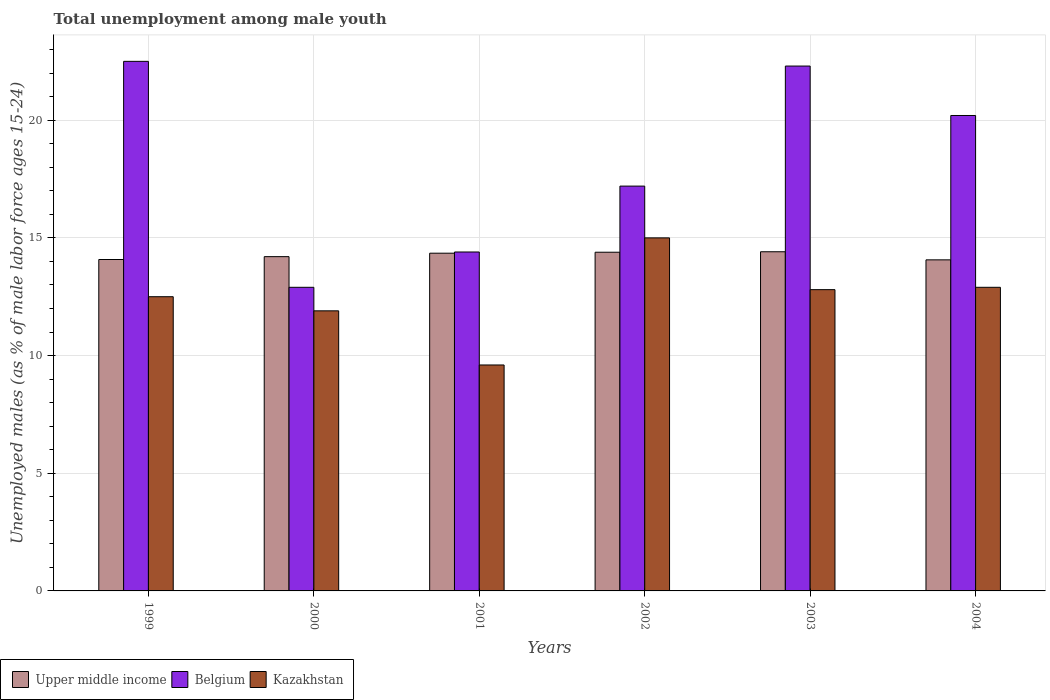How many different coloured bars are there?
Your response must be concise. 3. What is the percentage of unemployed males in in Upper middle income in 2000?
Your answer should be compact. 14.2. Across all years, what is the maximum percentage of unemployed males in in Belgium?
Your answer should be very brief. 22.5. Across all years, what is the minimum percentage of unemployed males in in Upper middle income?
Offer a terse response. 14.07. In which year was the percentage of unemployed males in in Upper middle income minimum?
Your answer should be very brief. 2004. What is the total percentage of unemployed males in in Upper middle income in the graph?
Offer a terse response. 85.5. What is the difference between the percentage of unemployed males in in Kazakhstan in 2001 and the percentage of unemployed males in in Upper middle income in 1999?
Provide a succinct answer. -4.48. What is the average percentage of unemployed males in in Belgium per year?
Your answer should be compact. 18.25. In the year 2002, what is the difference between the percentage of unemployed males in in Kazakhstan and percentage of unemployed males in in Belgium?
Provide a succinct answer. -2.2. What is the ratio of the percentage of unemployed males in in Upper middle income in 1999 to that in 2002?
Keep it short and to the point. 0.98. Is the percentage of unemployed males in in Upper middle income in 1999 less than that in 2003?
Ensure brevity in your answer.  Yes. Is the difference between the percentage of unemployed males in in Kazakhstan in 2001 and 2003 greater than the difference between the percentage of unemployed males in in Belgium in 2001 and 2003?
Offer a terse response. Yes. What is the difference between the highest and the second highest percentage of unemployed males in in Belgium?
Give a very brief answer. 0.2. What is the difference between the highest and the lowest percentage of unemployed males in in Upper middle income?
Your answer should be compact. 0.34. What does the 1st bar from the left in 2004 represents?
Offer a terse response. Upper middle income. What does the 3rd bar from the right in 1999 represents?
Your answer should be very brief. Upper middle income. Are all the bars in the graph horizontal?
Provide a succinct answer. No. Are the values on the major ticks of Y-axis written in scientific E-notation?
Provide a succinct answer. No. Does the graph contain any zero values?
Your response must be concise. No. Does the graph contain grids?
Offer a terse response. Yes. What is the title of the graph?
Offer a terse response. Total unemployment among male youth. What is the label or title of the Y-axis?
Provide a short and direct response. Unemployed males (as % of male labor force ages 15-24). What is the Unemployed males (as % of male labor force ages 15-24) in Upper middle income in 1999?
Give a very brief answer. 14.08. What is the Unemployed males (as % of male labor force ages 15-24) in Kazakhstan in 1999?
Make the answer very short. 12.5. What is the Unemployed males (as % of male labor force ages 15-24) of Upper middle income in 2000?
Offer a terse response. 14.2. What is the Unemployed males (as % of male labor force ages 15-24) of Belgium in 2000?
Offer a terse response. 12.9. What is the Unemployed males (as % of male labor force ages 15-24) of Kazakhstan in 2000?
Provide a succinct answer. 11.9. What is the Unemployed males (as % of male labor force ages 15-24) of Upper middle income in 2001?
Provide a short and direct response. 14.35. What is the Unemployed males (as % of male labor force ages 15-24) in Belgium in 2001?
Give a very brief answer. 14.4. What is the Unemployed males (as % of male labor force ages 15-24) in Kazakhstan in 2001?
Give a very brief answer. 9.6. What is the Unemployed males (as % of male labor force ages 15-24) of Upper middle income in 2002?
Provide a short and direct response. 14.39. What is the Unemployed males (as % of male labor force ages 15-24) in Belgium in 2002?
Offer a terse response. 17.2. What is the Unemployed males (as % of male labor force ages 15-24) in Kazakhstan in 2002?
Make the answer very short. 15. What is the Unemployed males (as % of male labor force ages 15-24) in Upper middle income in 2003?
Provide a succinct answer. 14.41. What is the Unemployed males (as % of male labor force ages 15-24) in Belgium in 2003?
Offer a very short reply. 22.3. What is the Unemployed males (as % of male labor force ages 15-24) in Kazakhstan in 2003?
Give a very brief answer. 12.8. What is the Unemployed males (as % of male labor force ages 15-24) in Upper middle income in 2004?
Make the answer very short. 14.07. What is the Unemployed males (as % of male labor force ages 15-24) of Belgium in 2004?
Offer a terse response. 20.2. What is the Unemployed males (as % of male labor force ages 15-24) of Kazakhstan in 2004?
Offer a terse response. 12.9. Across all years, what is the maximum Unemployed males (as % of male labor force ages 15-24) of Upper middle income?
Provide a succinct answer. 14.41. Across all years, what is the minimum Unemployed males (as % of male labor force ages 15-24) in Upper middle income?
Ensure brevity in your answer.  14.07. Across all years, what is the minimum Unemployed males (as % of male labor force ages 15-24) in Belgium?
Your answer should be compact. 12.9. Across all years, what is the minimum Unemployed males (as % of male labor force ages 15-24) of Kazakhstan?
Your answer should be compact. 9.6. What is the total Unemployed males (as % of male labor force ages 15-24) in Upper middle income in the graph?
Provide a succinct answer. 85.5. What is the total Unemployed males (as % of male labor force ages 15-24) in Belgium in the graph?
Provide a short and direct response. 109.5. What is the total Unemployed males (as % of male labor force ages 15-24) of Kazakhstan in the graph?
Your response must be concise. 74.7. What is the difference between the Unemployed males (as % of male labor force ages 15-24) in Upper middle income in 1999 and that in 2000?
Offer a very short reply. -0.12. What is the difference between the Unemployed males (as % of male labor force ages 15-24) of Kazakhstan in 1999 and that in 2000?
Offer a terse response. 0.6. What is the difference between the Unemployed males (as % of male labor force ages 15-24) in Upper middle income in 1999 and that in 2001?
Offer a terse response. -0.27. What is the difference between the Unemployed males (as % of male labor force ages 15-24) in Belgium in 1999 and that in 2001?
Provide a short and direct response. 8.1. What is the difference between the Unemployed males (as % of male labor force ages 15-24) in Upper middle income in 1999 and that in 2002?
Make the answer very short. -0.31. What is the difference between the Unemployed males (as % of male labor force ages 15-24) in Belgium in 1999 and that in 2002?
Provide a short and direct response. 5.3. What is the difference between the Unemployed males (as % of male labor force ages 15-24) in Upper middle income in 1999 and that in 2003?
Keep it short and to the point. -0.33. What is the difference between the Unemployed males (as % of male labor force ages 15-24) of Kazakhstan in 1999 and that in 2003?
Your response must be concise. -0.3. What is the difference between the Unemployed males (as % of male labor force ages 15-24) in Upper middle income in 1999 and that in 2004?
Your answer should be compact. 0.01. What is the difference between the Unemployed males (as % of male labor force ages 15-24) in Belgium in 1999 and that in 2004?
Offer a very short reply. 2.3. What is the difference between the Unemployed males (as % of male labor force ages 15-24) in Upper middle income in 2000 and that in 2001?
Your answer should be very brief. -0.15. What is the difference between the Unemployed males (as % of male labor force ages 15-24) in Upper middle income in 2000 and that in 2002?
Make the answer very short. -0.19. What is the difference between the Unemployed males (as % of male labor force ages 15-24) of Belgium in 2000 and that in 2002?
Your answer should be very brief. -4.3. What is the difference between the Unemployed males (as % of male labor force ages 15-24) in Upper middle income in 2000 and that in 2003?
Your response must be concise. -0.21. What is the difference between the Unemployed males (as % of male labor force ages 15-24) of Kazakhstan in 2000 and that in 2003?
Your response must be concise. -0.9. What is the difference between the Unemployed males (as % of male labor force ages 15-24) of Upper middle income in 2000 and that in 2004?
Offer a very short reply. 0.14. What is the difference between the Unemployed males (as % of male labor force ages 15-24) in Kazakhstan in 2000 and that in 2004?
Offer a terse response. -1. What is the difference between the Unemployed males (as % of male labor force ages 15-24) of Upper middle income in 2001 and that in 2002?
Provide a succinct answer. -0.04. What is the difference between the Unemployed males (as % of male labor force ages 15-24) in Kazakhstan in 2001 and that in 2002?
Offer a very short reply. -5.4. What is the difference between the Unemployed males (as % of male labor force ages 15-24) in Upper middle income in 2001 and that in 2003?
Ensure brevity in your answer.  -0.06. What is the difference between the Unemployed males (as % of male labor force ages 15-24) in Kazakhstan in 2001 and that in 2003?
Provide a succinct answer. -3.2. What is the difference between the Unemployed males (as % of male labor force ages 15-24) in Upper middle income in 2001 and that in 2004?
Offer a terse response. 0.28. What is the difference between the Unemployed males (as % of male labor force ages 15-24) in Belgium in 2001 and that in 2004?
Provide a succinct answer. -5.8. What is the difference between the Unemployed males (as % of male labor force ages 15-24) in Kazakhstan in 2001 and that in 2004?
Your answer should be compact. -3.3. What is the difference between the Unemployed males (as % of male labor force ages 15-24) in Upper middle income in 2002 and that in 2003?
Make the answer very short. -0.02. What is the difference between the Unemployed males (as % of male labor force ages 15-24) in Upper middle income in 2002 and that in 2004?
Offer a terse response. 0.32. What is the difference between the Unemployed males (as % of male labor force ages 15-24) of Belgium in 2002 and that in 2004?
Keep it short and to the point. -3. What is the difference between the Unemployed males (as % of male labor force ages 15-24) in Kazakhstan in 2002 and that in 2004?
Give a very brief answer. 2.1. What is the difference between the Unemployed males (as % of male labor force ages 15-24) of Upper middle income in 2003 and that in 2004?
Your answer should be very brief. 0.34. What is the difference between the Unemployed males (as % of male labor force ages 15-24) in Belgium in 2003 and that in 2004?
Your answer should be very brief. 2.1. What is the difference between the Unemployed males (as % of male labor force ages 15-24) of Upper middle income in 1999 and the Unemployed males (as % of male labor force ages 15-24) of Belgium in 2000?
Your answer should be very brief. 1.18. What is the difference between the Unemployed males (as % of male labor force ages 15-24) in Upper middle income in 1999 and the Unemployed males (as % of male labor force ages 15-24) in Kazakhstan in 2000?
Offer a very short reply. 2.18. What is the difference between the Unemployed males (as % of male labor force ages 15-24) of Belgium in 1999 and the Unemployed males (as % of male labor force ages 15-24) of Kazakhstan in 2000?
Provide a short and direct response. 10.6. What is the difference between the Unemployed males (as % of male labor force ages 15-24) in Upper middle income in 1999 and the Unemployed males (as % of male labor force ages 15-24) in Belgium in 2001?
Make the answer very short. -0.32. What is the difference between the Unemployed males (as % of male labor force ages 15-24) in Upper middle income in 1999 and the Unemployed males (as % of male labor force ages 15-24) in Kazakhstan in 2001?
Offer a terse response. 4.48. What is the difference between the Unemployed males (as % of male labor force ages 15-24) in Belgium in 1999 and the Unemployed males (as % of male labor force ages 15-24) in Kazakhstan in 2001?
Your answer should be very brief. 12.9. What is the difference between the Unemployed males (as % of male labor force ages 15-24) in Upper middle income in 1999 and the Unemployed males (as % of male labor force ages 15-24) in Belgium in 2002?
Offer a terse response. -3.12. What is the difference between the Unemployed males (as % of male labor force ages 15-24) of Upper middle income in 1999 and the Unemployed males (as % of male labor force ages 15-24) of Kazakhstan in 2002?
Ensure brevity in your answer.  -0.92. What is the difference between the Unemployed males (as % of male labor force ages 15-24) in Belgium in 1999 and the Unemployed males (as % of male labor force ages 15-24) in Kazakhstan in 2002?
Keep it short and to the point. 7.5. What is the difference between the Unemployed males (as % of male labor force ages 15-24) of Upper middle income in 1999 and the Unemployed males (as % of male labor force ages 15-24) of Belgium in 2003?
Offer a terse response. -8.22. What is the difference between the Unemployed males (as % of male labor force ages 15-24) of Upper middle income in 1999 and the Unemployed males (as % of male labor force ages 15-24) of Kazakhstan in 2003?
Your answer should be compact. 1.28. What is the difference between the Unemployed males (as % of male labor force ages 15-24) in Belgium in 1999 and the Unemployed males (as % of male labor force ages 15-24) in Kazakhstan in 2003?
Ensure brevity in your answer.  9.7. What is the difference between the Unemployed males (as % of male labor force ages 15-24) in Upper middle income in 1999 and the Unemployed males (as % of male labor force ages 15-24) in Belgium in 2004?
Give a very brief answer. -6.12. What is the difference between the Unemployed males (as % of male labor force ages 15-24) of Upper middle income in 1999 and the Unemployed males (as % of male labor force ages 15-24) of Kazakhstan in 2004?
Make the answer very short. 1.18. What is the difference between the Unemployed males (as % of male labor force ages 15-24) of Belgium in 1999 and the Unemployed males (as % of male labor force ages 15-24) of Kazakhstan in 2004?
Ensure brevity in your answer.  9.6. What is the difference between the Unemployed males (as % of male labor force ages 15-24) in Upper middle income in 2000 and the Unemployed males (as % of male labor force ages 15-24) in Belgium in 2001?
Provide a succinct answer. -0.2. What is the difference between the Unemployed males (as % of male labor force ages 15-24) of Upper middle income in 2000 and the Unemployed males (as % of male labor force ages 15-24) of Kazakhstan in 2001?
Keep it short and to the point. 4.6. What is the difference between the Unemployed males (as % of male labor force ages 15-24) in Belgium in 2000 and the Unemployed males (as % of male labor force ages 15-24) in Kazakhstan in 2001?
Offer a very short reply. 3.3. What is the difference between the Unemployed males (as % of male labor force ages 15-24) in Upper middle income in 2000 and the Unemployed males (as % of male labor force ages 15-24) in Belgium in 2002?
Offer a terse response. -3. What is the difference between the Unemployed males (as % of male labor force ages 15-24) of Upper middle income in 2000 and the Unemployed males (as % of male labor force ages 15-24) of Kazakhstan in 2002?
Your response must be concise. -0.8. What is the difference between the Unemployed males (as % of male labor force ages 15-24) in Belgium in 2000 and the Unemployed males (as % of male labor force ages 15-24) in Kazakhstan in 2002?
Make the answer very short. -2.1. What is the difference between the Unemployed males (as % of male labor force ages 15-24) in Upper middle income in 2000 and the Unemployed males (as % of male labor force ages 15-24) in Belgium in 2003?
Provide a succinct answer. -8.1. What is the difference between the Unemployed males (as % of male labor force ages 15-24) of Upper middle income in 2000 and the Unemployed males (as % of male labor force ages 15-24) of Kazakhstan in 2003?
Keep it short and to the point. 1.4. What is the difference between the Unemployed males (as % of male labor force ages 15-24) in Upper middle income in 2000 and the Unemployed males (as % of male labor force ages 15-24) in Belgium in 2004?
Offer a terse response. -6. What is the difference between the Unemployed males (as % of male labor force ages 15-24) in Upper middle income in 2000 and the Unemployed males (as % of male labor force ages 15-24) in Kazakhstan in 2004?
Offer a very short reply. 1.3. What is the difference between the Unemployed males (as % of male labor force ages 15-24) in Upper middle income in 2001 and the Unemployed males (as % of male labor force ages 15-24) in Belgium in 2002?
Keep it short and to the point. -2.85. What is the difference between the Unemployed males (as % of male labor force ages 15-24) of Upper middle income in 2001 and the Unemployed males (as % of male labor force ages 15-24) of Kazakhstan in 2002?
Make the answer very short. -0.65. What is the difference between the Unemployed males (as % of male labor force ages 15-24) in Upper middle income in 2001 and the Unemployed males (as % of male labor force ages 15-24) in Belgium in 2003?
Give a very brief answer. -7.95. What is the difference between the Unemployed males (as % of male labor force ages 15-24) of Upper middle income in 2001 and the Unemployed males (as % of male labor force ages 15-24) of Kazakhstan in 2003?
Your answer should be compact. 1.55. What is the difference between the Unemployed males (as % of male labor force ages 15-24) in Belgium in 2001 and the Unemployed males (as % of male labor force ages 15-24) in Kazakhstan in 2003?
Provide a short and direct response. 1.6. What is the difference between the Unemployed males (as % of male labor force ages 15-24) of Upper middle income in 2001 and the Unemployed males (as % of male labor force ages 15-24) of Belgium in 2004?
Provide a succinct answer. -5.85. What is the difference between the Unemployed males (as % of male labor force ages 15-24) in Upper middle income in 2001 and the Unemployed males (as % of male labor force ages 15-24) in Kazakhstan in 2004?
Keep it short and to the point. 1.45. What is the difference between the Unemployed males (as % of male labor force ages 15-24) in Belgium in 2001 and the Unemployed males (as % of male labor force ages 15-24) in Kazakhstan in 2004?
Give a very brief answer. 1.5. What is the difference between the Unemployed males (as % of male labor force ages 15-24) in Upper middle income in 2002 and the Unemployed males (as % of male labor force ages 15-24) in Belgium in 2003?
Offer a very short reply. -7.91. What is the difference between the Unemployed males (as % of male labor force ages 15-24) of Upper middle income in 2002 and the Unemployed males (as % of male labor force ages 15-24) of Kazakhstan in 2003?
Offer a terse response. 1.59. What is the difference between the Unemployed males (as % of male labor force ages 15-24) in Upper middle income in 2002 and the Unemployed males (as % of male labor force ages 15-24) in Belgium in 2004?
Ensure brevity in your answer.  -5.81. What is the difference between the Unemployed males (as % of male labor force ages 15-24) of Upper middle income in 2002 and the Unemployed males (as % of male labor force ages 15-24) of Kazakhstan in 2004?
Keep it short and to the point. 1.49. What is the difference between the Unemployed males (as % of male labor force ages 15-24) in Belgium in 2002 and the Unemployed males (as % of male labor force ages 15-24) in Kazakhstan in 2004?
Offer a terse response. 4.3. What is the difference between the Unemployed males (as % of male labor force ages 15-24) of Upper middle income in 2003 and the Unemployed males (as % of male labor force ages 15-24) of Belgium in 2004?
Make the answer very short. -5.79. What is the difference between the Unemployed males (as % of male labor force ages 15-24) of Upper middle income in 2003 and the Unemployed males (as % of male labor force ages 15-24) of Kazakhstan in 2004?
Your response must be concise. 1.51. What is the average Unemployed males (as % of male labor force ages 15-24) of Upper middle income per year?
Ensure brevity in your answer.  14.25. What is the average Unemployed males (as % of male labor force ages 15-24) in Belgium per year?
Provide a succinct answer. 18.25. What is the average Unemployed males (as % of male labor force ages 15-24) in Kazakhstan per year?
Offer a terse response. 12.45. In the year 1999, what is the difference between the Unemployed males (as % of male labor force ages 15-24) of Upper middle income and Unemployed males (as % of male labor force ages 15-24) of Belgium?
Your answer should be very brief. -8.42. In the year 1999, what is the difference between the Unemployed males (as % of male labor force ages 15-24) of Upper middle income and Unemployed males (as % of male labor force ages 15-24) of Kazakhstan?
Offer a very short reply. 1.58. In the year 1999, what is the difference between the Unemployed males (as % of male labor force ages 15-24) in Belgium and Unemployed males (as % of male labor force ages 15-24) in Kazakhstan?
Your answer should be very brief. 10. In the year 2000, what is the difference between the Unemployed males (as % of male labor force ages 15-24) in Upper middle income and Unemployed males (as % of male labor force ages 15-24) in Belgium?
Ensure brevity in your answer.  1.3. In the year 2000, what is the difference between the Unemployed males (as % of male labor force ages 15-24) of Upper middle income and Unemployed males (as % of male labor force ages 15-24) of Kazakhstan?
Keep it short and to the point. 2.3. In the year 2000, what is the difference between the Unemployed males (as % of male labor force ages 15-24) in Belgium and Unemployed males (as % of male labor force ages 15-24) in Kazakhstan?
Provide a succinct answer. 1. In the year 2001, what is the difference between the Unemployed males (as % of male labor force ages 15-24) in Upper middle income and Unemployed males (as % of male labor force ages 15-24) in Belgium?
Your answer should be very brief. -0.05. In the year 2001, what is the difference between the Unemployed males (as % of male labor force ages 15-24) of Upper middle income and Unemployed males (as % of male labor force ages 15-24) of Kazakhstan?
Your answer should be very brief. 4.75. In the year 2002, what is the difference between the Unemployed males (as % of male labor force ages 15-24) of Upper middle income and Unemployed males (as % of male labor force ages 15-24) of Belgium?
Your response must be concise. -2.81. In the year 2002, what is the difference between the Unemployed males (as % of male labor force ages 15-24) of Upper middle income and Unemployed males (as % of male labor force ages 15-24) of Kazakhstan?
Give a very brief answer. -0.61. In the year 2003, what is the difference between the Unemployed males (as % of male labor force ages 15-24) in Upper middle income and Unemployed males (as % of male labor force ages 15-24) in Belgium?
Your answer should be compact. -7.89. In the year 2003, what is the difference between the Unemployed males (as % of male labor force ages 15-24) of Upper middle income and Unemployed males (as % of male labor force ages 15-24) of Kazakhstan?
Your answer should be compact. 1.61. In the year 2003, what is the difference between the Unemployed males (as % of male labor force ages 15-24) of Belgium and Unemployed males (as % of male labor force ages 15-24) of Kazakhstan?
Your answer should be compact. 9.5. In the year 2004, what is the difference between the Unemployed males (as % of male labor force ages 15-24) of Upper middle income and Unemployed males (as % of male labor force ages 15-24) of Belgium?
Your answer should be compact. -6.13. In the year 2004, what is the difference between the Unemployed males (as % of male labor force ages 15-24) of Upper middle income and Unemployed males (as % of male labor force ages 15-24) of Kazakhstan?
Offer a very short reply. 1.17. What is the ratio of the Unemployed males (as % of male labor force ages 15-24) in Belgium in 1999 to that in 2000?
Ensure brevity in your answer.  1.74. What is the ratio of the Unemployed males (as % of male labor force ages 15-24) in Kazakhstan in 1999 to that in 2000?
Offer a very short reply. 1.05. What is the ratio of the Unemployed males (as % of male labor force ages 15-24) in Upper middle income in 1999 to that in 2001?
Give a very brief answer. 0.98. What is the ratio of the Unemployed males (as % of male labor force ages 15-24) of Belgium in 1999 to that in 2001?
Provide a short and direct response. 1.56. What is the ratio of the Unemployed males (as % of male labor force ages 15-24) of Kazakhstan in 1999 to that in 2001?
Ensure brevity in your answer.  1.3. What is the ratio of the Unemployed males (as % of male labor force ages 15-24) of Upper middle income in 1999 to that in 2002?
Ensure brevity in your answer.  0.98. What is the ratio of the Unemployed males (as % of male labor force ages 15-24) of Belgium in 1999 to that in 2002?
Your answer should be compact. 1.31. What is the ratio of the Unemployed males (as % of male labor force ages 15-24) of Upper middle income in 1999 to that in 2003?
Provide a succinct answer. 0.98. What is the ratio of the Unemployed males (as % of male labor force ages 15-24) in Belgium in 1999 to that in 2003?
Provide a succinct answer. 1.01. What is the ratio of the Unemployed males (as % of male labor force ages 15-24) of Kazakhstan in 1999 to that in 2003?
Give a very brief answer. 0.98. What is the ratio of the Unemployed males (as % of male labor force ages 15-24) of Upper middle income in 1999 to that in 2004?
Make the answer very short. 1. What is the ratio of the Unemployed males (as % of male labor force ages 15-24) of Belgium in 1999 to that in 2004?
Your answer should be compact. 1.11. What is the ratio of the Unemployed males (as % of male labor force ages 15-24) of Belgium in 2000 to that in 2001?
Provide a short and direct response. 0.9. What is the ratio of the Unemployed males (as % of male labor force ages 15-24) of Kazakhstan in 2000 to that in 2001?
Provide a succinct answer. 1.24. What is the ratio of the Unemployed males (as % of male labor force ages 15-24) of Upper middle income in 2000 to that in 2002?
Your answer should be compact. 0.99. What is the ratio of the Unemployed males (as % of male labor force ages 15-24) in Belgium in 2000 to that in 2002?
Offer a very short reply. 0.75. What is the ratio of the Unemployed males (as % of male labor force ages 15-24) of Kazakhstan in 2000 to that in 2002?
Ensure brevity in your answer.  0.79. What is the ratio of the Unemployed males (as % of male labor force ages 15-24) in Upper middle income in 2000 to that in 2003?
Give a very brief answer. 0.99. What is the ratio of the Unemployed males (as % of male labor force ages 15-24) in Belgium in 2000 to that in 2003?
Keep it short and to the point. 0.58. What is the ratio of the Unemployed males (as % of male labor force ages 15-24) in Kazakhstan in 2000 to that in 2003?
Your answer should be very brief. 0.93. What is the ratio of the Unemployed males (as % of male labor force ages 15-24) of Upper middle income in 2000 to that in 2004?
Provide a succinct answer. 1.01. What is the ratio of the Unemployed males (as % of male labor force ages 15-24) of Belgium in 2000 to that in 2004?
Your answer should be very brief. 0.64. What is the ratio of the Unemployed males (as % of male labor force ages 15-24) in Kazakhstan in 2000 to that in 2004?
Offer a terse response. 0.92. What is the ratio of the Unemployed males (as % of male labor force ages 15-24) of Upper middle income in 2001 to that in 2002?
Your answer should be compact. 1. What is the ratio of the Unemployed males (as % of male labor force ages 15-24) in Belgium in 2001 to that in 2002?
Make the answer very short. 0.84. What is the ratio of the Unemployed males (as % of male labor force ages 15-24) in Kazakhstan in 2001 to that in 2002?
Give a very brief answer. 0.64. What is the ratio of the Unemployed males (as % of male labor force ages 15-24) in Upper middle income in 2001 to that in 2003?
Offer a terse response. 1. What is the ratio of the Unemployed males (as % of male labor force ages 15-24) in Belgium in 2001 to that in 2003?
Give a very brief answer. 0.65. What is the ratio of the Unemployed males (as % of male labor force ages 15-24) of Upper middle income in 2001 to that in 2004?
Provide a succinct answer. 1.02. What is the ratio of the Unemployed males (as % of male labor force ages 15-24) of Belgium in 2001 to that in 2004?
Provide a short and direct response. 0.71. What is the ratio of the Unemployed males (as % of male labor force ages 15-24) in Kazakhstan in 2001 to that in 2004?
Offer a very short reply. 0.74. What is the ratio of the Unemployed males (as % of male labor force ages 15-24) of Upper middle income in 2002 to that in 2003?
Your answer should be compact. 1. What is the ratio of the Unemployed males (as % of male labor force ages 15-24) of Belgium in 2002 to that in 2003?
Provide a succinct answer. 0.77. What is the ratio of the Unemployed males (as % of male labor force ages 15-24) in Kazakhstan in 2002 to that in 2003?
Keep it short and to the point. 1.17. What is the ratio of the Unemployed males (as % of male labor force ages 15-24) in Upper middle income in 2002 to that in 2004?
Provide a succinct answer. 1.02. What is the ratio of the Unemployed males (as % of male labor force ages 15-24) of Belgium in 2002 to that in 2004?
Provide a succinct answer. 0.85. What is the ratio of the Unemployed males (as % of male labor force ages 15-24) in Kazakhstan in 2002 to that in 2004?
Ensure brevity in your answer.  1.16. What is the ratio of the Unemployed males (as % of male labor force ages 15-24) of Upper middle income in 2003 to that in 2004?
Provide a succinct answer. 1.02. What is the ratio of the Unemployed males (as % of male labor force ages 15-24) in Belgium in 2003 to that in 2004?
Keep it short and to the point. 1.1. What is the difference between the highest and the second highest Unemployed males (as % of male labor force ages 15-24) of Upper middle income?
Your response must be concise. 0.02. What is the difference between the highest and the second highest Unemployed males (as % of male labor force ages 15-24) in Belgium?
Make the answer very short. 0.2. What is the difference between the highest and the lowest Unemployed males (as % of male labor force ages 15-24) of Upper middle income?
Give a very brief answer. 0.34. What is the difference between the highest and the lowest Unemployed males (as % of male labor force ages 15-24) in Belgium?
Your answer should be very brief. 9.6. What is the difference between the highest and the lowest Unemployed males (as % of male labor force ages 15-24) in Kazakhstan?
Provide a short and direct response. 5.4. 